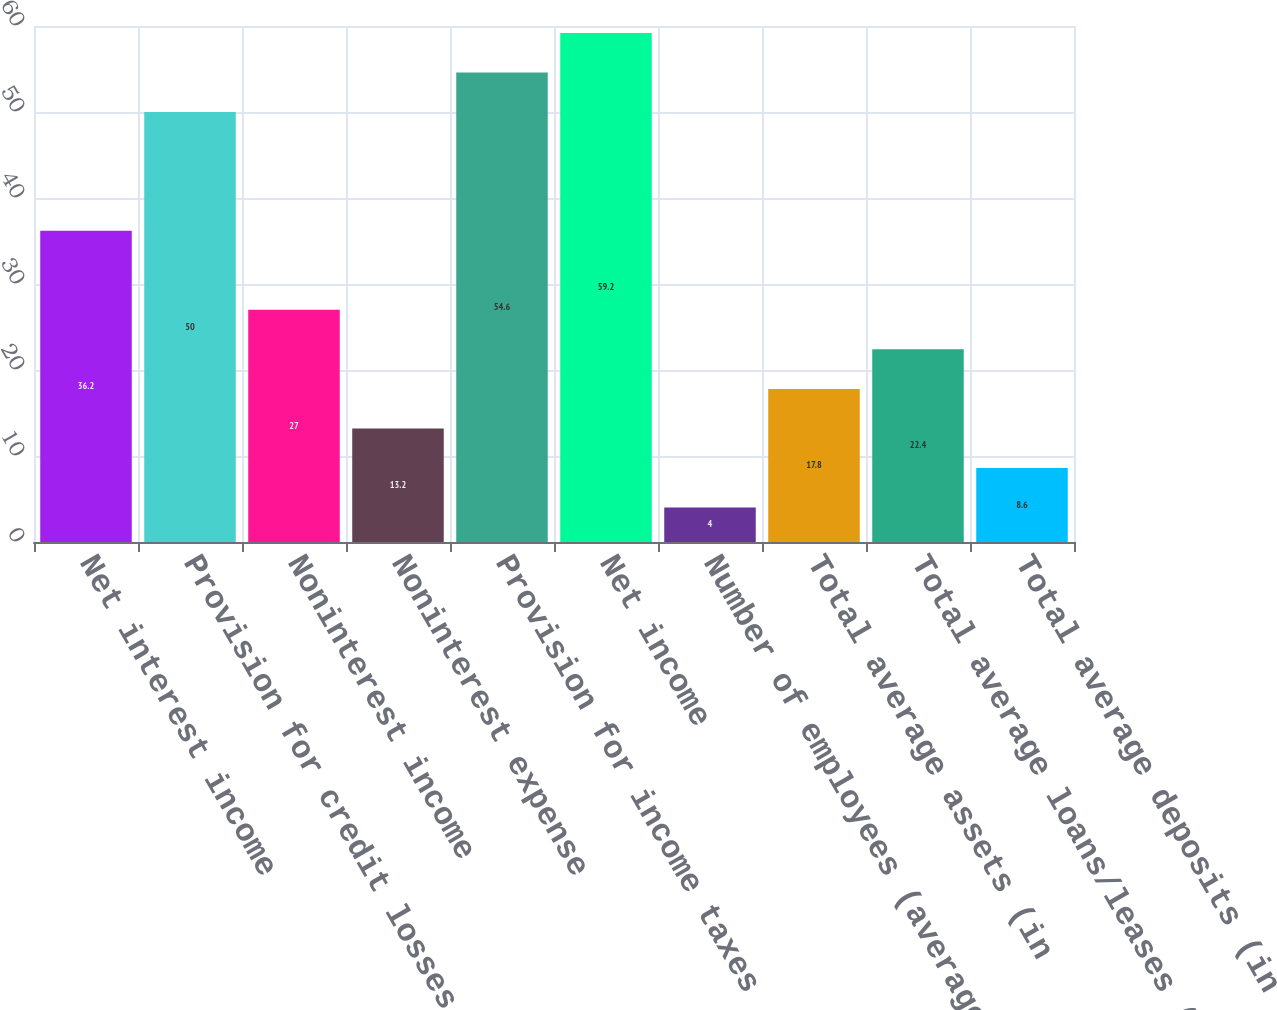<chart> <loc_0><loc_0><loc_500><loc_500><bar_chart><fcel>Net interest income<fcel>Provision for credit losses<fcel>Noninterest income<fcel>Noninterest expense<fcel>Provision for income taxes<fcel>Net income<fcel>Number of employees (average<fcel>Total average assets (in<fcel>Total average loans/leases (in<fcel>Total average deposits (in<nl><fcel>36.2<fcel>50<fcel>27<fcel>13.2<fcel>54.6<fcel>59.2<fcel>4<fcel>17.8<fcel>22.4<fcel>8.6<nl></chart> 